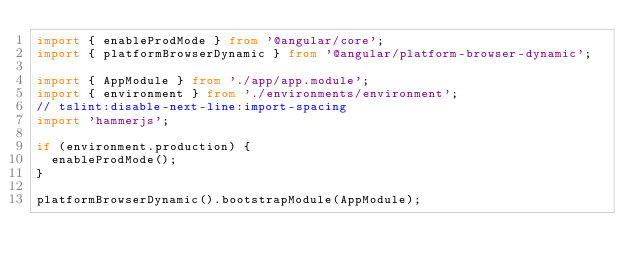<code> <loc_0><loc_0><loc_500><loc_500><_TypeScript_>import { enableProdMode } from '@angular/core';
import { platformBrowserDynamic } from '@angular/platform-browser-dynamic';

import { AppModule } from './app/app.module';
import { environment } from './environments/environment';
// tslint:disable-next-line:import-spacing
import 'hammerjs';

if (environment.production) {
  enableProdMode();
}

platformBrowserDynamic().bootstrapModule(AppModule);
</code> 